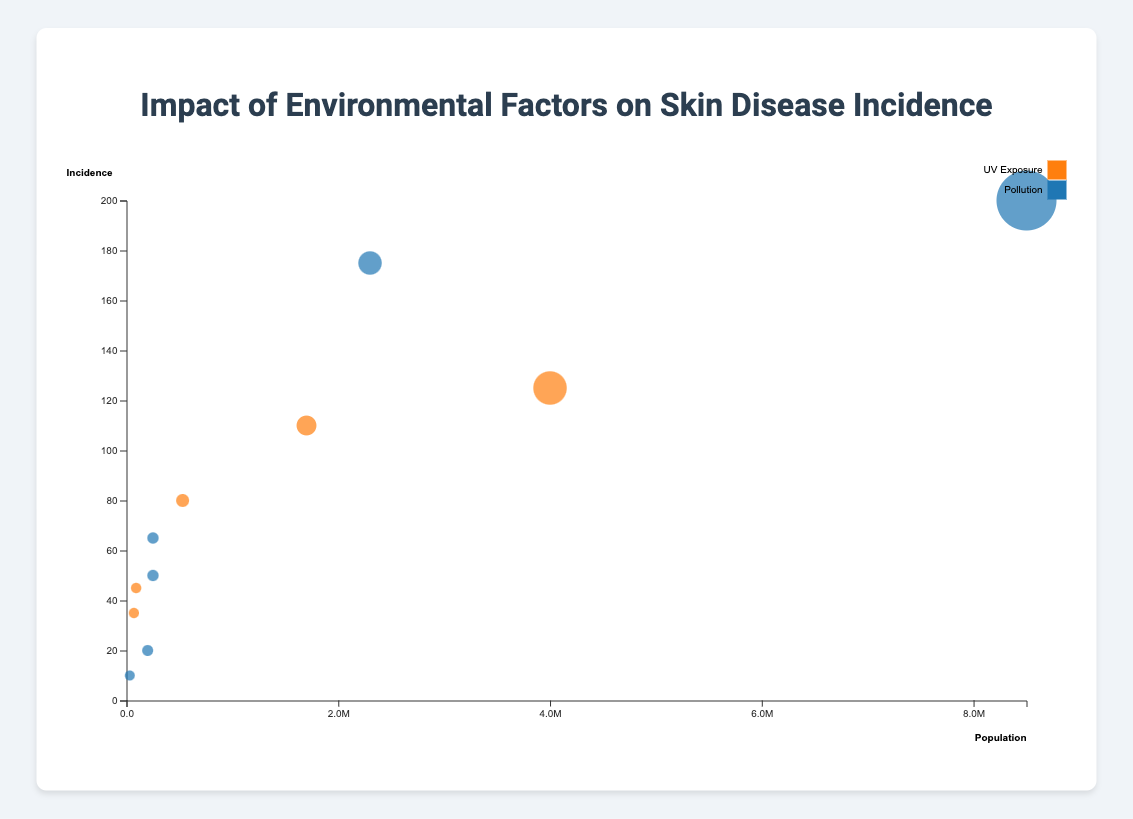How many cities are represented in the bubble chart? The figure shows individual data points representing different cities. To find the number of distinct cities, count each unique city name in the dataset. There are 11 cities represented.
Answer: 11 Which environmental factor has more associated cities in the dataset? The figure uses different colors to represent the environmental factors UV Exposure and Pollution. Counting the number of cities for each factor: UV Exposure has 6 cities (Los Angeles, Fresno, Redding, Phoenix, Flagstaff, Redding) while Pollution has 5 cities (New York City, Buffalo, Ithaca, Houston, Lubbock). Therefore, UV Exposure has more associated cities.
Answer: UV Exposure What is the relationship between population size and incidence in Los Angeles? Find the bubble representing Los Angeles. It is plotted with its population on the x-axis and incidence on the y-axis. Los Angeles has a high population of 4,000,000 and an incidence of 125 cases. Thus, in Los Angeles, higher population size correlates with higher incidence.
Answer: Higher population, higher incidence Which city has the highest incidence of skin diseases due to Pollution? Look for the bubbles representing cities influenced by Pollution (colored differently). Among them, identify the one with the highest incidence. New York City has the highest incidence at 200 cases.
Answer: New York City What is the average incidence of skin disease in rural areas exposed to UV? Identify the rural areas affected by UV exposure: Redding and Flagstaff, with incidences of 45 and 35, respectively. Average these values: (45 + 35) / 2 = 40.
Answer: 40 Which urban area has the smallest population but a high incidence of skin disease due to Pollution? Focus on urban areas affected by Pollution. Identify the one with smallest population but high incidence. Buffalo has a population of 250,000 and an incidence of 65, which is considered high for its population size.
Answer: Buffalo Compare the incidences of skin diseases due to UV exposure in Phoenix and Los Angeles. Locate the data points for Phoenix (110 incidences) and Los Angeles (125 incidences). Los Angeles has a slightly higher incidence of skin diseases due to UV exposure than Phoenix.
Answer: Los Angeles has higher incidence What is the ratio of the incidence to population size for Redding exposed to UV? Redding has a population of 91,000 and an incidence of 45. The ratio is calculated as 45/91,000 = 0.0004945, or approximately 0.000495 when rounded up.
Answer: 0.000495 How does incidence of skin disease differ between urban and rural areas exposed to Pollution? Compare urban cities (New York City, Buffalo, Houston, Lubbock) and rural areas (Ithaca, Amarillo). Urban areas have higher incidences collectively compared to rural areas, suggesting a higher impact of pollution on skin diseases in urban settings.
Answer: Urban areas have higher incidence 